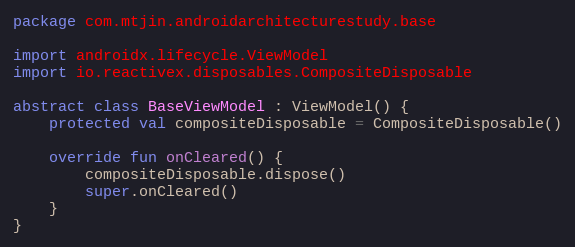Convert code to text. <code><loc_0><loc_0><loc_500><loc_500><_Kotlin_>package com.mtjin.androidarchitecturestudy.base

import androidx.lifecycle.ViewModel
import io.reactivex.disposables.CompositeDisposable

abstract class BaseViewModel : ViewModel() {
    protected val compositeDisposable = CompositeDisposable()

    override fun onCleared() {
        compositeDisposable.dispose()
        super.onCleared()
    }
}</code> 